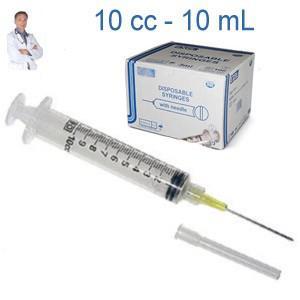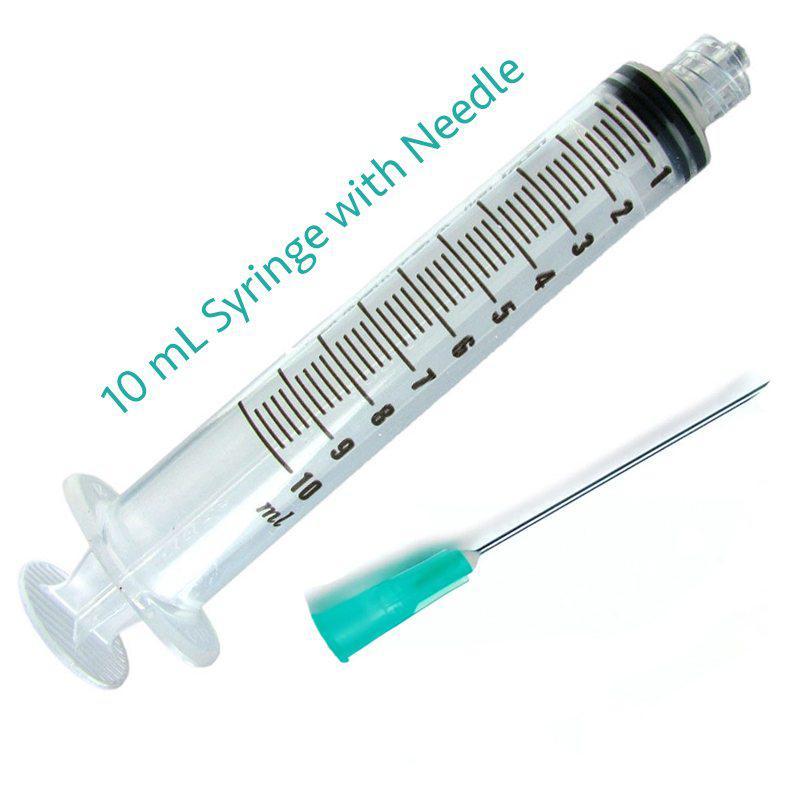The first image is the image on the left, the second image is the image on the right. Considering the images on both sides, is "There are exactly two syringes." valid? Answer yes or no. Yes. The first image is the image on the left, the second image is the image on the right. Evaluate the accuracy of this statement regarding the images: "In the image to the right, the needle is NOT connected to the syringe; the syringe cannot presently enter the skin.". Is it true? Answer yes or no. Yes. 